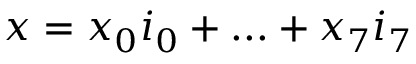<formula> <loc_0><loc_0><loc_500><loc_500>x = x _ { 0 } i _ { 0 } + \dots + x _ { 7 } i _ { 7 }</formula> 